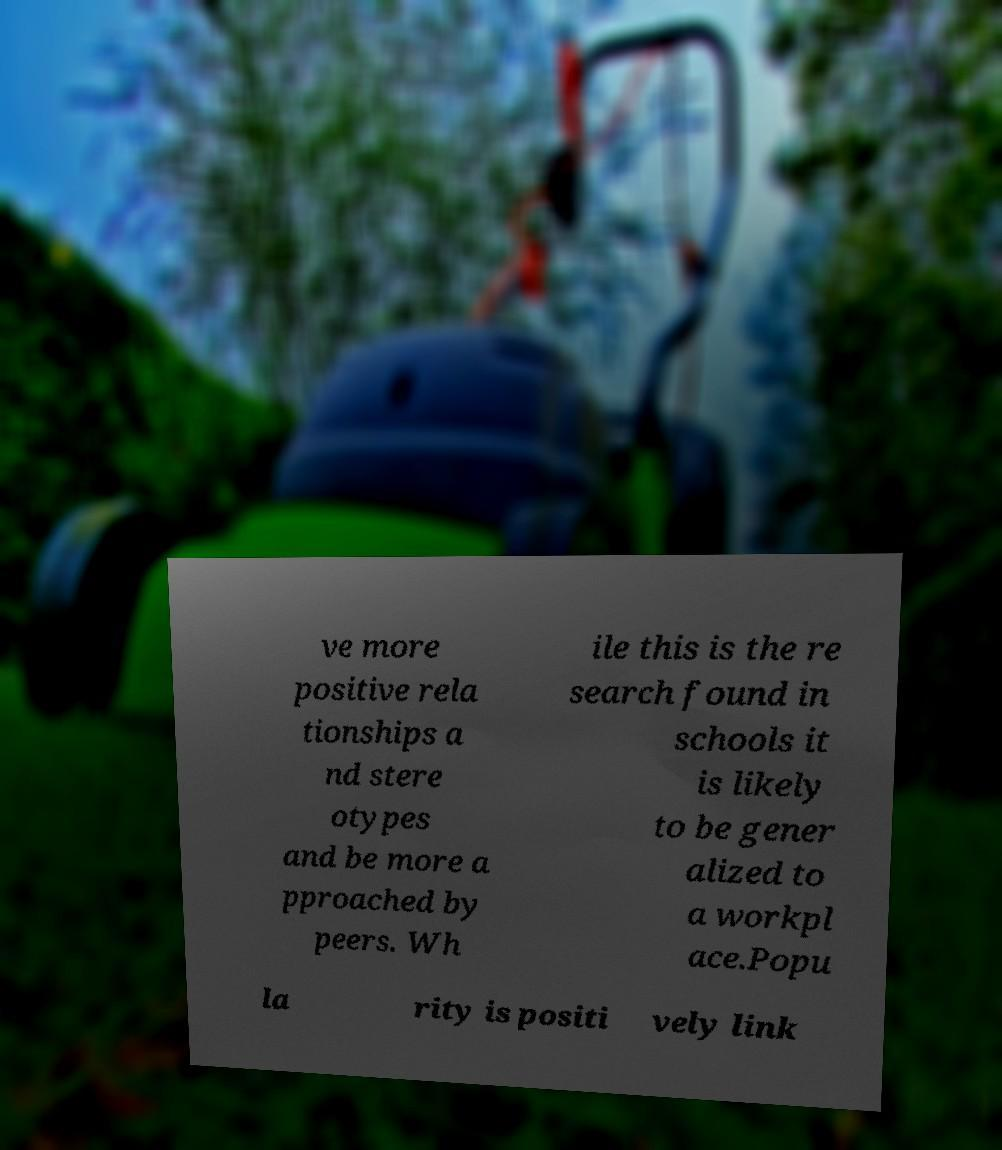Could you assist in decoding the text presented in this image and type it out clearly? ve more positive rela tionships a nd stere otypes and be more a pproached by peers. Wh ile this is the re search found in schools it is likely to be gener alized to a workpl ace.Popu la rity is positi vely link 